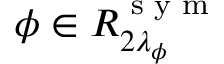Convert formula to latex. <formula><loc_0><loc_0><loc_500><loc_500>\phi \in R _ { 2 \lambda _ { \phi } } ^ { s y m }</formula> 